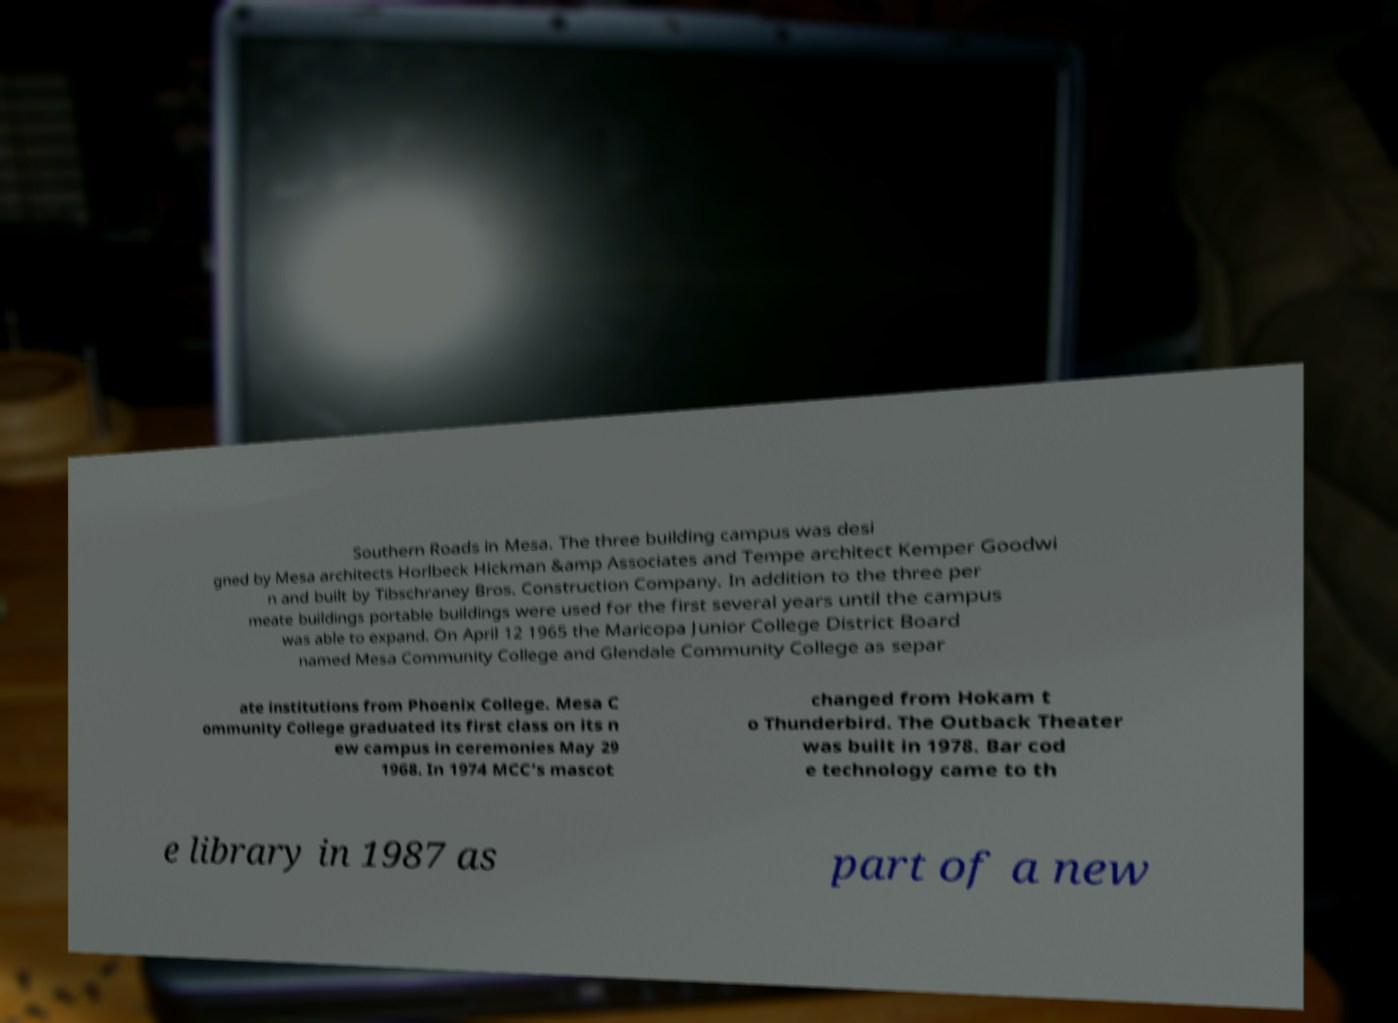Can you accurately transcribe the text from the provided image for me? Southern Roads in Mesa. The three building campus was desi gned by Mesa architects Horlbeck Hickman &amp Associates and Tempe architect Kemper Goodwi n and built by Tibschraney Bros. Construction Company. In addition to the three per meate buildings portable buildings were used for the first several years until the campus was able to expand. On April 12 1965 the Maricopa Junior College District Board named Mesa Community College and Glendale Community College as separ ate institutions from Phoenix College. Mesa C ommunity College graduated its first class on its n ew campus in ceremonies May 29 1968. In 1974 MCC’s mascot changed from Hokam t o Thunderbird. The Outback Theater was built in 1978. Bar cod e technology came to th e library in 1987 as part of a new 